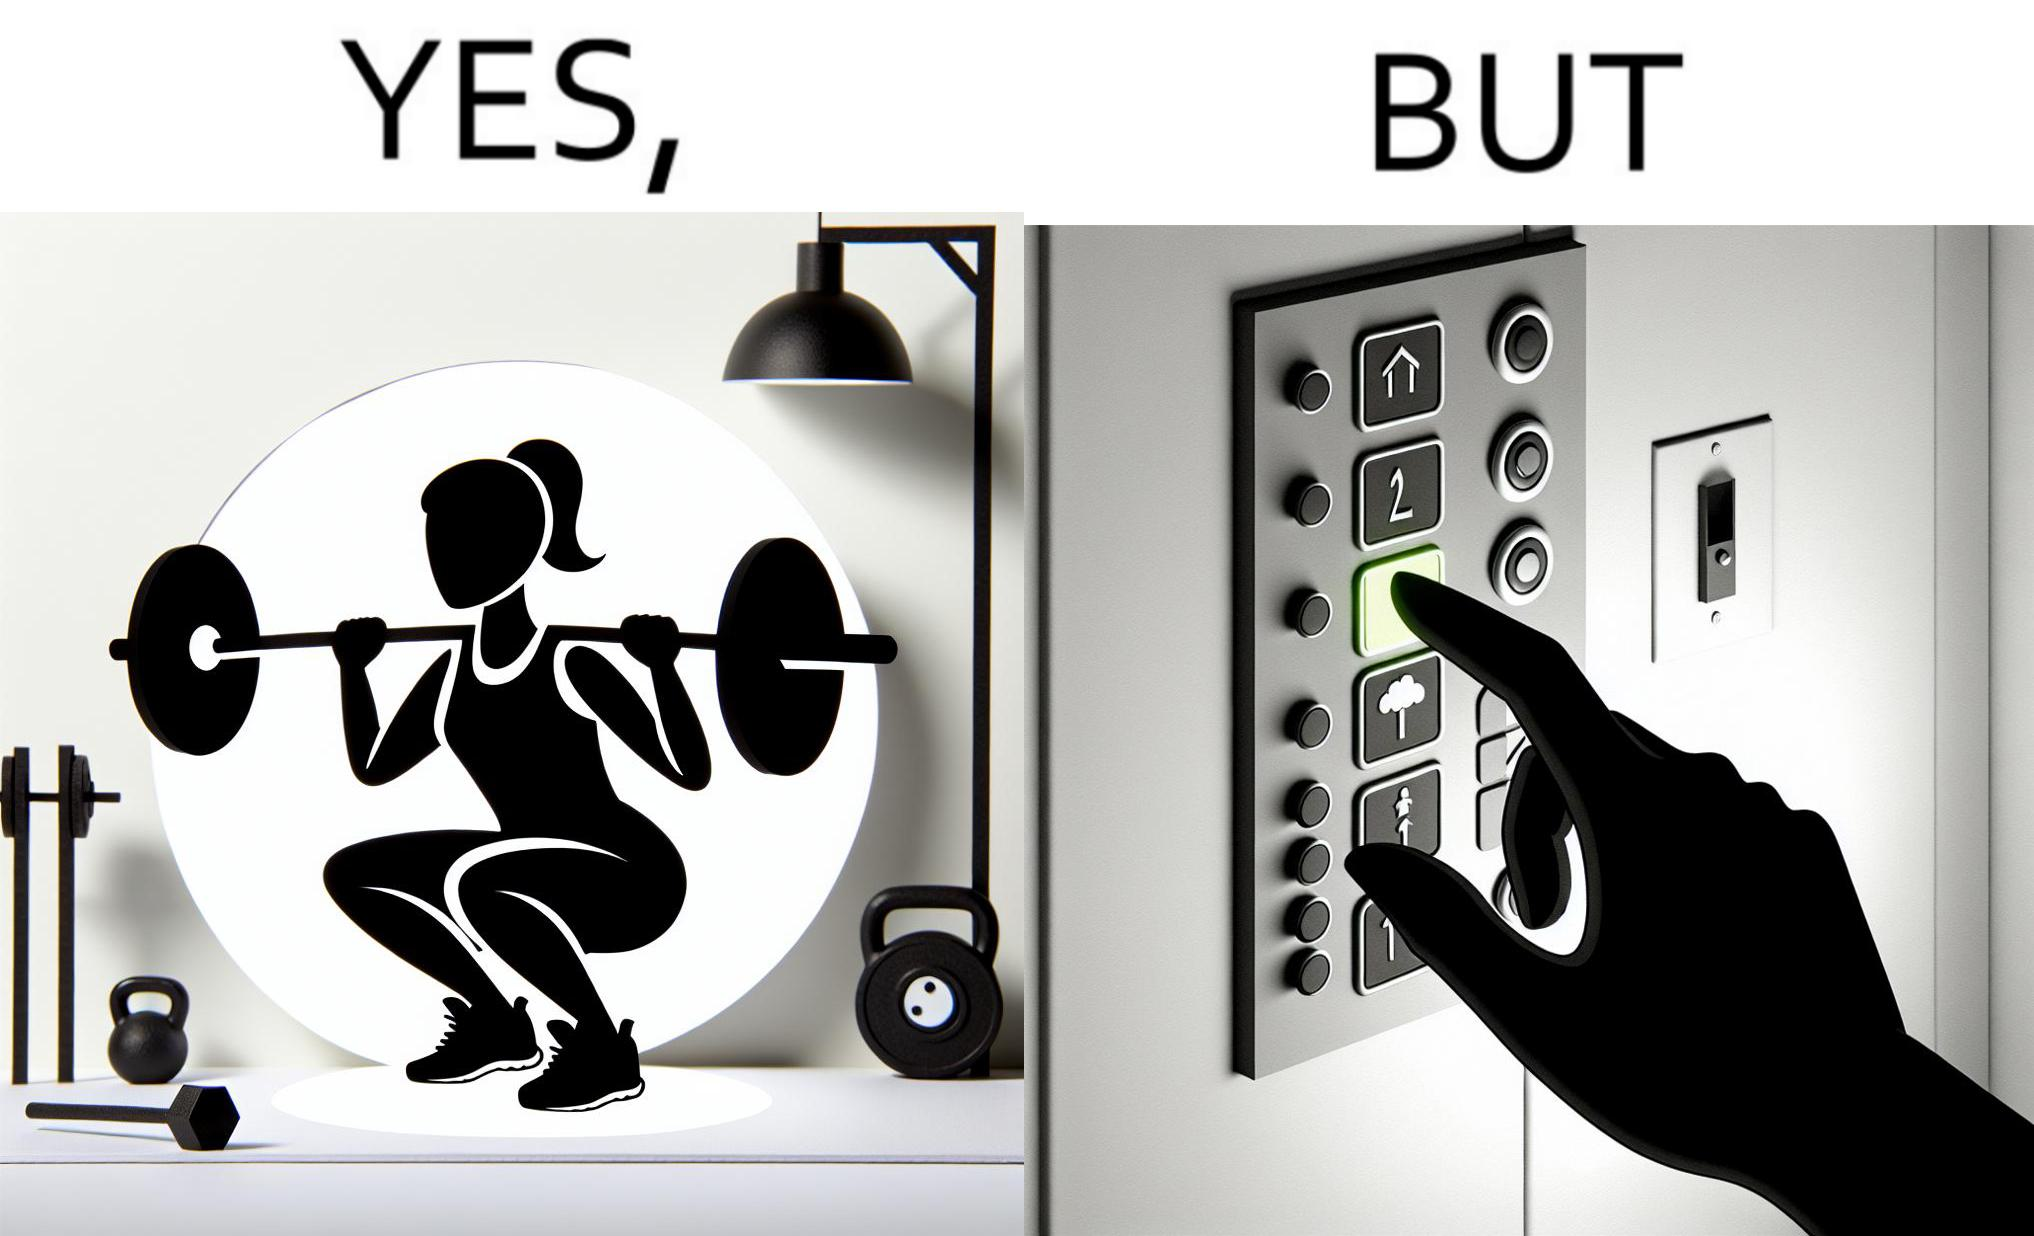Describe the satirical element in this image. The image is satirical because it shows that while people do various kinds of exercises and go to gym to stay fit, they avoid doing simplest of physical tasks like using stairs instead of elevators to get to even the first or the second floor of a building. 